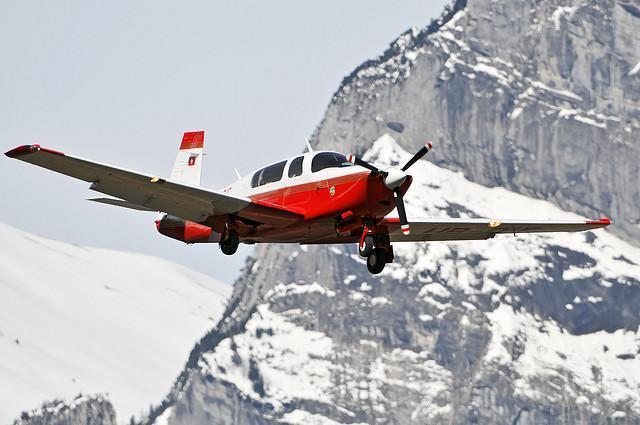How many apples (the entire apple or part of an apple) can be seen in this picture?
Give a very brief answer. 0. 